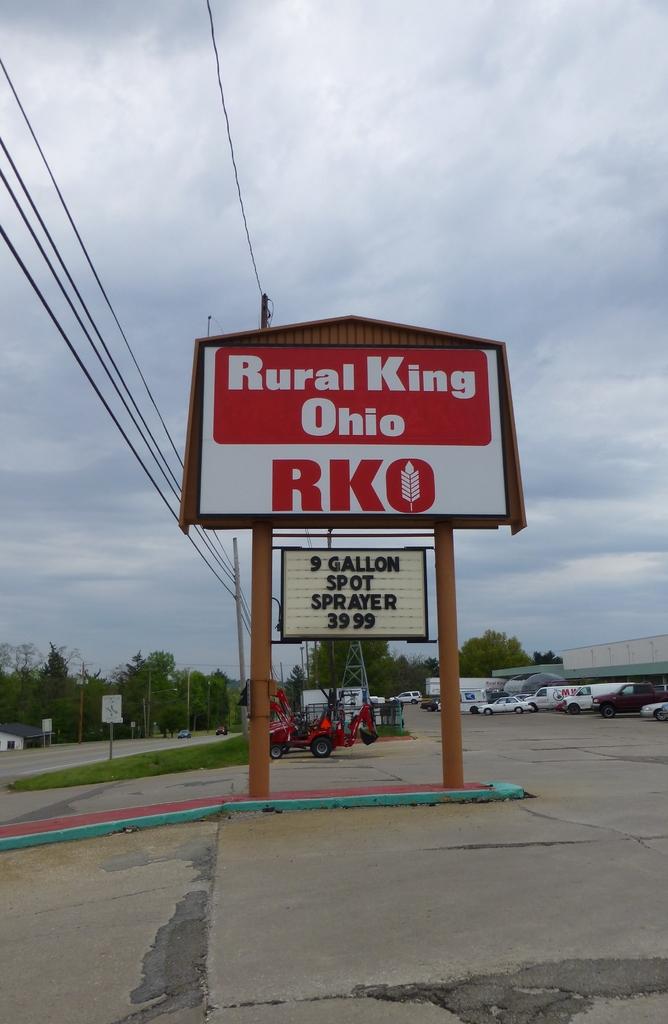What state is the rurai king in?
Offer a terse response. Ohio. How much is the sprayer?
Offer a terse response. 39.99. 